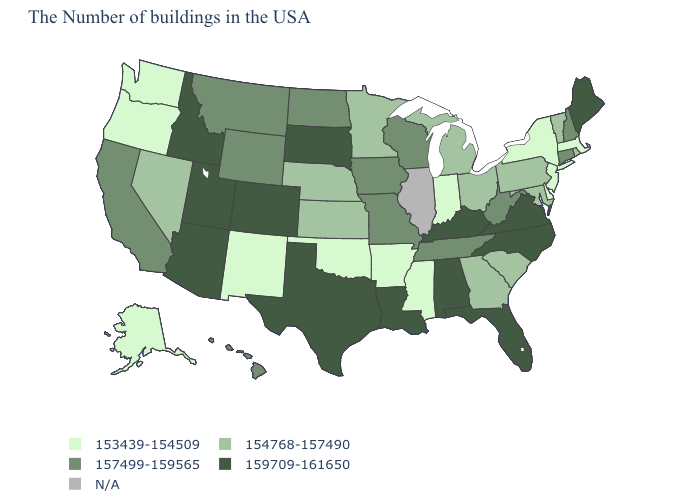Among the states that border Connecticut , which have the lowest value?
Write a very short answer. Massachusetts, New York. Which states have the lowest value in the USA?
Concise answer only. Massachusetts, New York, New Jersey, Delaware, Indiana, Mississippi, Arkansas, Oklahoma, New Mexico, Washington, Oregon, Alaska. What is the highest value in the USA?
Be succinct. 159709-161650. How many symbols are there in the legend?
Quick response, please. 5. Does Oregon have the highest value in the West?
Be succinct. No. Among the states that border Kansas , which have the lowest value?
Be succinct. Oklahoma. Name the states that have a value in the range 154768-157490?
Concise answer only. Rhode Island, Vermont, Maryland, Pennsylvania, South Carolina, Ohio, Georgia, Michigan, Minnesota, Kansas, Nebraska, Nevada. Which states have the highest value in the USA?
Give a very brief answer. Maine, Virginia, North Carolina, Florida, Kentucky, Alabama, Louisiana, Texas, South Dakota, Colorado, Utah, Arizona, Idaho. What is the value of Wisconsin?
Answer briefly. 157499-159565. Does Arizona have the highest value in the West?
Be succinct. Yes. Name the states that have a value in the range 154768-157490?
Be succinct. Rhode Island, Vermont, Maryland, Pennsylvania, South Carolina, Ohio, Georgia, Michigan, Minnesota, Kansas, Nebraska, Nevada. Name the states that have a value in the range 159709-161650?
Write a very short answer. Maine, Virginia, North Carolina, Florida, Kentucky, Alabama, Louisiana, Texas, South Dakota, Colorado, Utah, Arizona, Idaho. What is the highest value in the USA?
Short answer required. 159709-161650. Does the map have missing data?
Quick response, please. Yes. Name the states that have a value in the range 159709-161650?
Keep it brief. Maine, Virginia, North Carolina, Florida, Kentucky, Alabama, Louisiana, Texas, South Dakota, Colorado, Utah, Arizona, Idaho. 